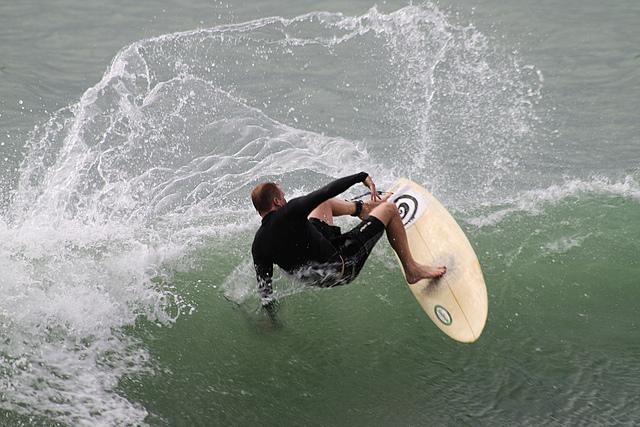Does it look like the surfer is about to hit the water?
Keep it brief. Yes. Is he doing this on a weekend?
Keep it brief. Yes. What activity is this?
Keep it brief. Surfing. 